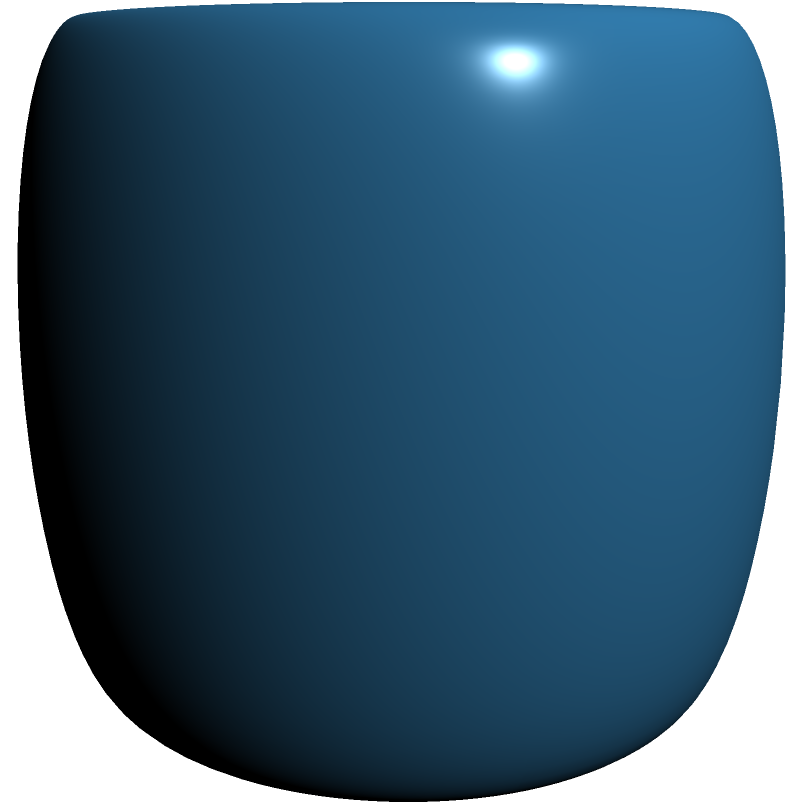Consider a torus with major radius $R=2$ and minor radius $a=0.5$, as shown in the figure. In quantum error correction, toroidal codes are often used due to their topological properties. Calculate the surface area of this torus and explain how this relates to the number of physical qubits required for a toroidal quantum code with distance $d = 3$. To solve this problem, we'll follow these steps:

1) The surface area of a torus is given by the formula:

   $$A = 4\pi^2 Ra$$

   where $R$ is the major radius and $a$ is the minor radius.

2) Substituting the given values:

   $$A = 4\pi^2 \cdot 2 \cdot 0.5 = 4\pi^2$$

3) Calculating this:

   $$A \approx 39.48 \text{ square units}$$

4) In toroidal quantum codes, the surface of the torus is typically divided into a lattice, where each cell represents a physical qubit. The number of physical qubits is related to the surface area.

5) For a toroidal code with distance $d$, we need at least $d^2$ physical qubits in each dimension of the torus. So, for $d = 3$, we need at least $3^2 = 9$ qubits in each dimension.

6) The total number of physical qubits is thus at least $9 \cdot 9 = 81$.

7) This lattice of 81 qubits would cover the surface area we calculated. The actual number of qubits used might be higher, depending on the specific code construction and desired error correction capabilities.

8) The relationship between the torus surface area and the number of qubits is not exactly linear, but generally, a larger surface area allows for more qubits to be encoded, potentially increasing the code's distance or the number of logical qubits that can be protected.
Answer: Surface area $\approx 39.48$ square units; at least 81 physical qubits needed for $d=3$ toroidal code 